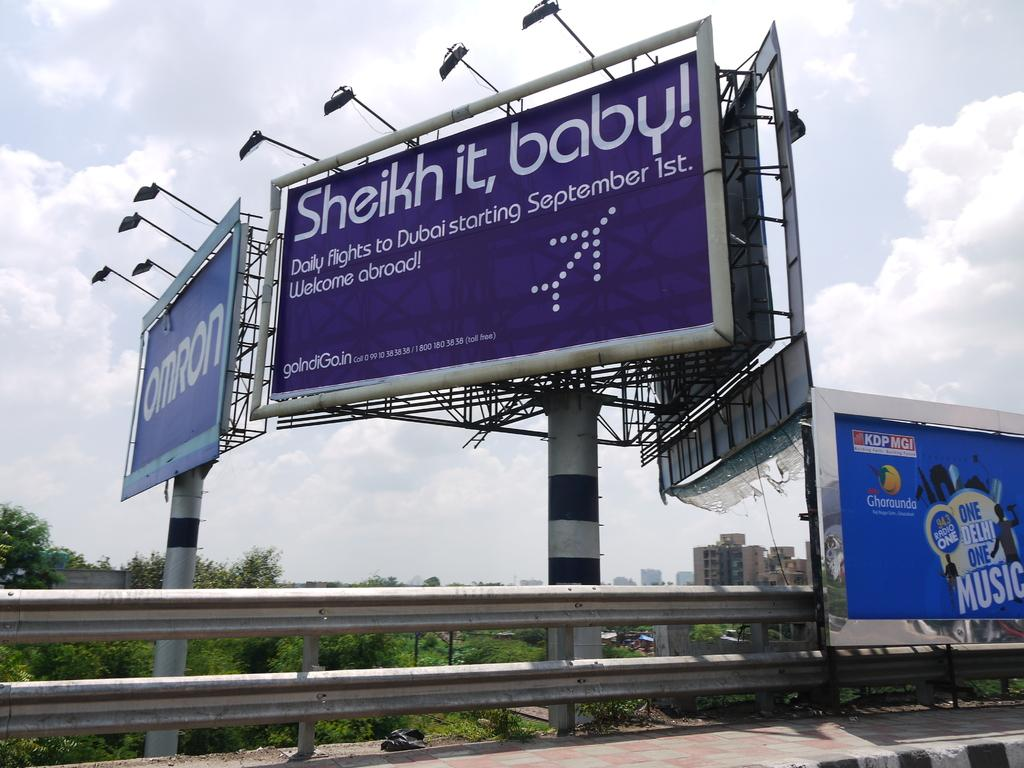Provide a one-sentence caption for the provided image. A purple billboard advertising for Dubai flights tells viewers to "Sheik it, baby!". 